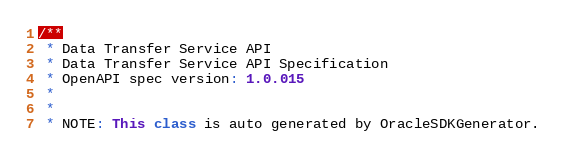<code> <loc_0><loc_0><loc_500><loc_500><_TypeScript_>/**
 * Data Transfer Service API
 * Data Transfer Service API Specification
 * OpenAPI spec version: 1.0.015
 *
 *
 * NOTE: This class is auto generated by OracleSDKGenerator.</code> 